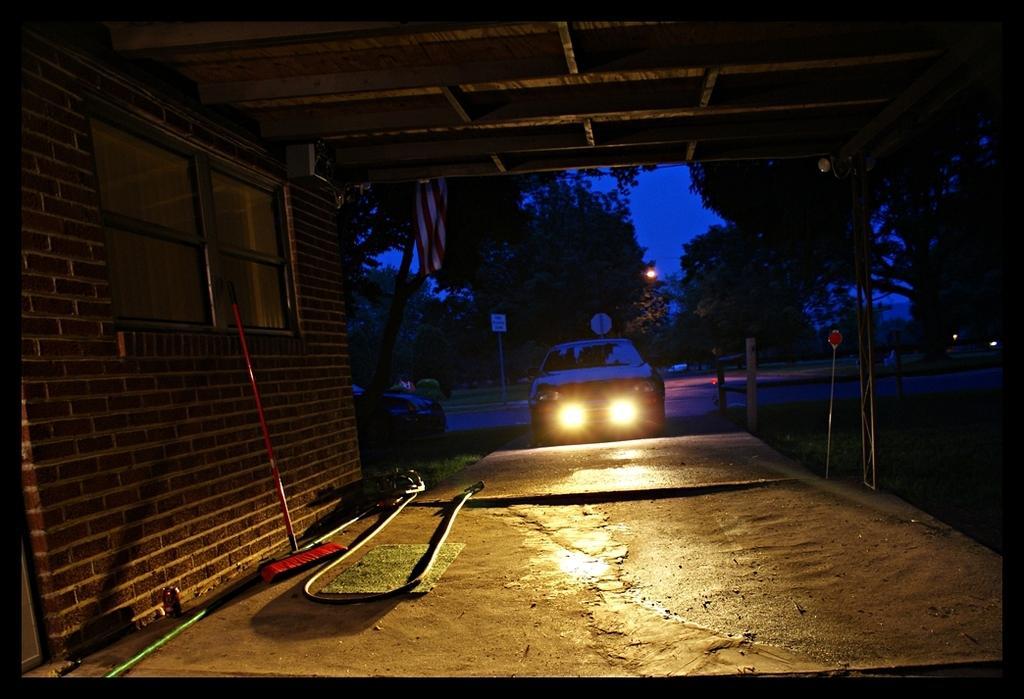Describe this image in one or two sentences. There is a car in the center of the image, there is a window, wiper, and a pipe on the left side and there is a roof at the top side and there are trees, sign poles, lamp, and sky in the background area, there is a flag in the image. 